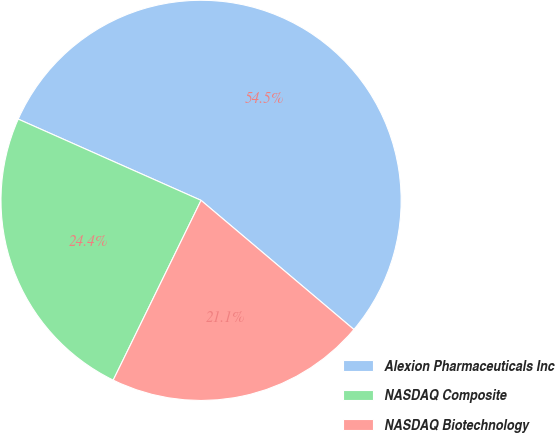Convert chart. <chart><loc_0><loc_0><loc_500><loc_500><pie_chart><fcel>Alexion Pharmaceuticals Inc<fcel>NASDAQ Composite<fcel>NASDAQ Biotechnology<nl><fcel>54.51%<fcel>24.42%<fcel>21.07%<nl></chart> 